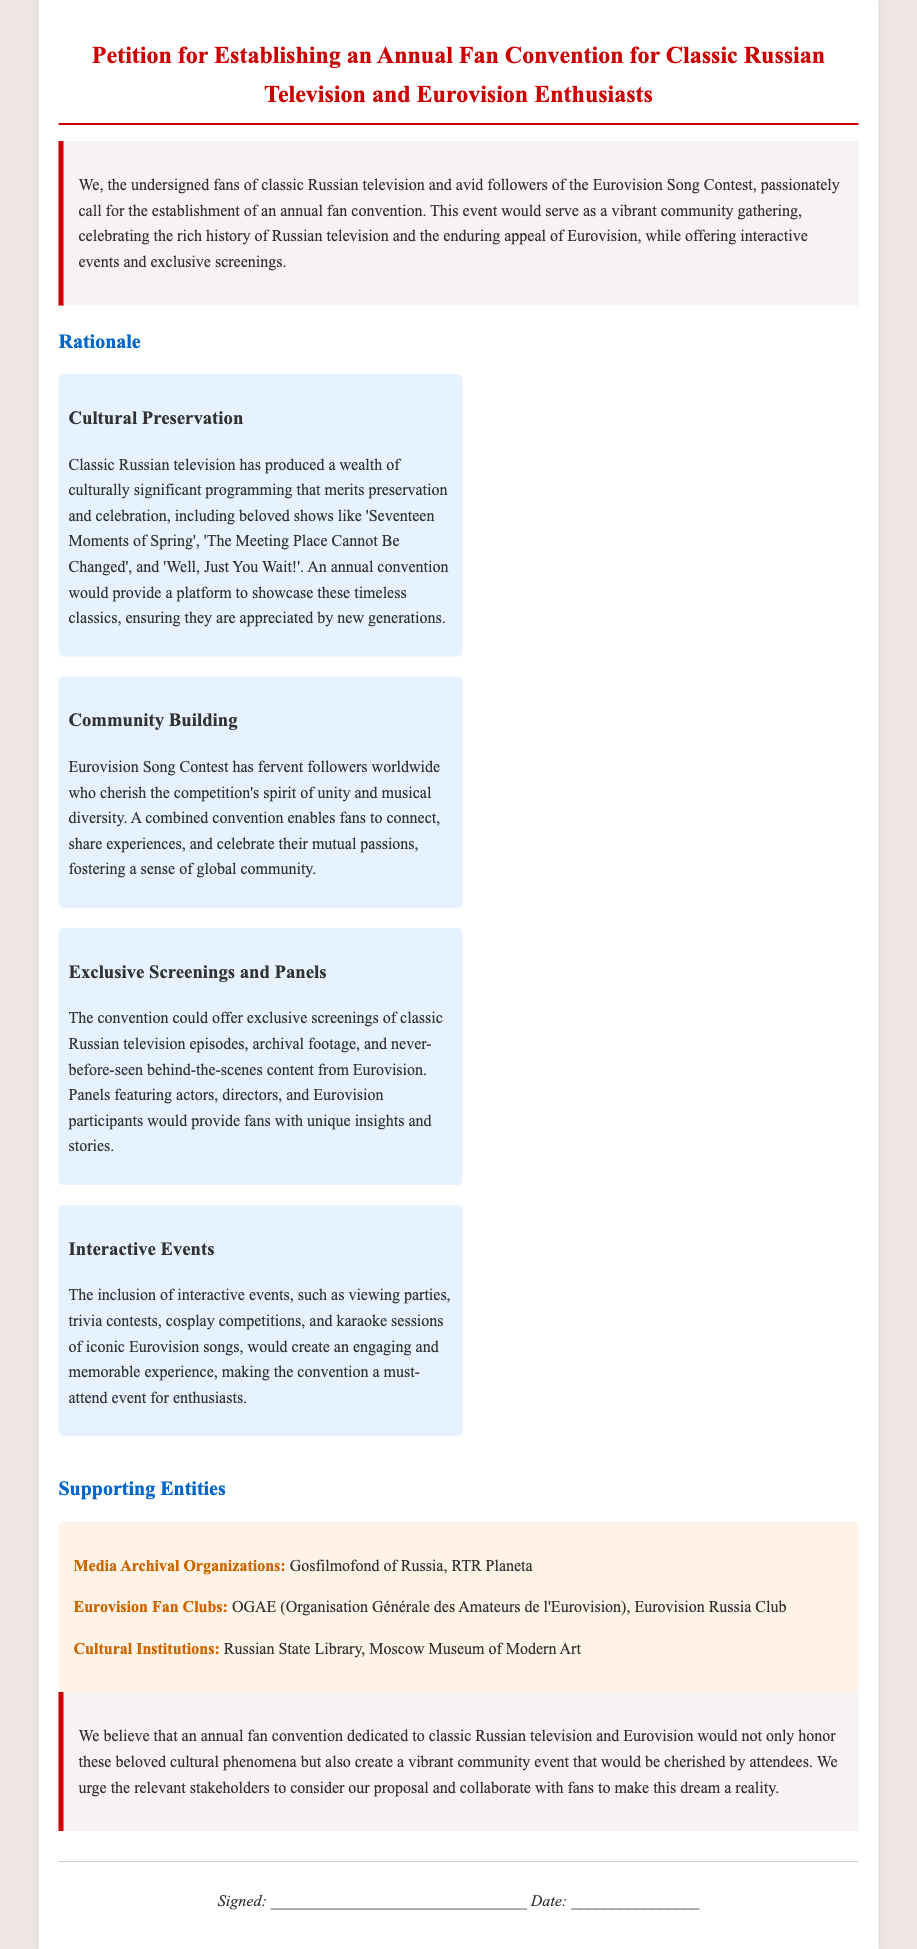What is the title of the petition? The title is prominently displayed at the top of the document as the main heading.
Answer: Petition for Establishing an Annual Fan Convention for Classic Russian Television and Eurovision Enthusiasts What are two classic Russian television shows mentioned? The document lists specific shows under cultural preservation that highlight classic Russian television.
Answer: Seventeen Moments of Spring, The Meeting Place Cannot Be Changed How many rationale sections are there? The rationale section discusses various aspects and is divided into items, providing different reasons for the convention.
Answer: Four Which organization is listed under Media Archival Organizations? The supporting entities section provides specific examples of organizations supporting the petition.
Answer: Gosfilmofond of Russia What kind of interactive events are mentioned for the convention? The document describes types of events that would engage attendees during the convention.
Answer: Viewing parties, trivia contests, cosplay competitions, karaoke sessions What is the main objective of the petition? The introduction and conclusion indicate the primary goal of the petition from the fans’ perspective.
Answer: Establishing an annual fan convention Who are two Eurovision Fan Clubs mentioned? The supporting entities section includes fan clubs associated with Eurovision.
Answer: OGAE, Eurovision Russia Club What is the color scheme used for the introduction section? The introduction section background color and text color are specified in the document's style and description.
Answer: Light pink background with dark text 